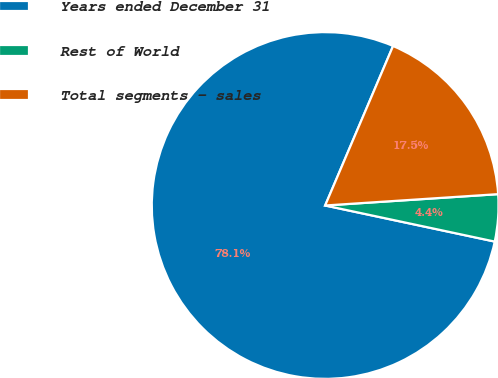<chart> <loc_0><loc_0><loc_500><loc_500><pie_chart><fcel>Years ended December 31<fcel>Rest of World<fcel>Total segments - sales<nl><fcel>78.07%<fcel>4.38%<fcel>17.55%<nl></chart> 